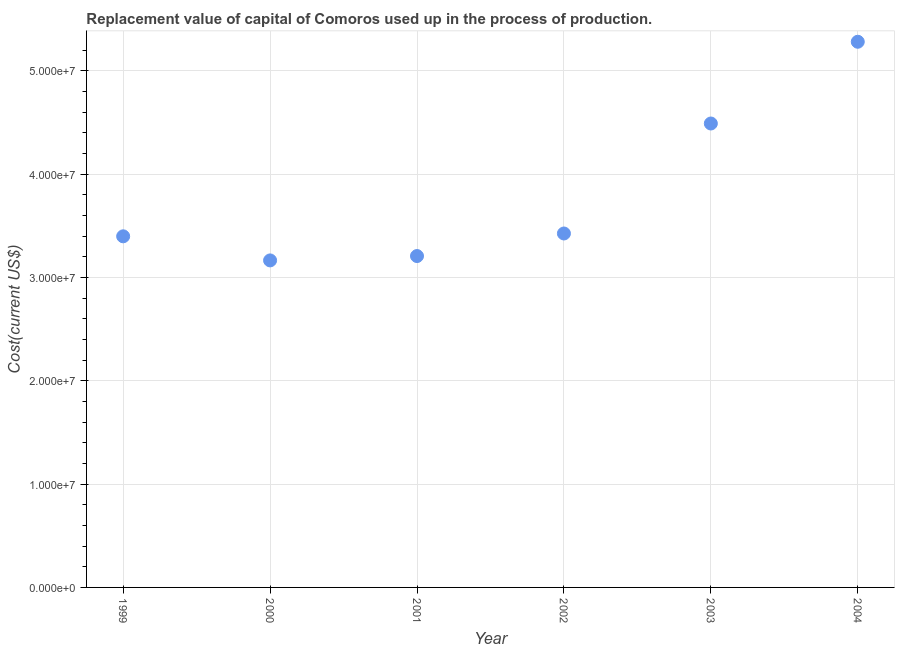What is the consumption of fixed capital in 2002?
Make the answer very short. 3.43e+07. Across all years, what is the maximum consumption of fixed capital?
Offer a very short reply. 5.28e+07. Across all years, what is the minimum consumption of fixed capital?
Your response must be concise. 3.16e+07. In which year was the consumption of fixed capital minimum?
Your response must be concise. 2000. What is the sum of the consumption of fixed capital?
Ensure brevity in your answer.  2.30e+08. What is the difference between the consumption of fixed capital in 1999 and 2001?
Make the answer very short. 1.91e+06. What is the average consumption of fixed capital per year?
Make the answer very short. 3.83e+07. What is the median consumption of fixed capital?
Ensure brevity in your answer.  3.41e+07. Do a majority of the years between 2000 and 2001 (inclusive) have consumption of fixed capital greater than 50000000 US$?
Provide a succinct answer. No. What is the ratio of the consumption of fixed capital in 2000 to that in 2004?
Your answer should be very brief. 0.6. What is the difference between the highest and the second highest consumption of fixed capital?
Your answer should be very brief. 7.91e+06. Is the sum of the consumption of fixed capital in 1999 and 2000 greater than the maximum consumption of fixed capital across all years?
Provide a short and direct response. Yes. What is the difference between the highest and the lowest consumption of fixed capital?
Make the answer very short. 2.12e+07. In how many years, is the consumption of fixed capital greater than the average consumption of fixed capital taken over all years?
Provide a succinct answer. 2. How many dotlines are there?
Keep it short and to the point. 1. How many years are there in the graph?
Your answer should be compact. 6. Are the values on the major ticks of Y-axis written in scientific E-notation?
Provide a short and direct response. Yes. Does the graph contain any zero values?
Provide a short and direct response. No. Does the graph contain grids?
Keep it short and to the point. Yes. What is the title of the graph?
Offer a terse response. Replacement value of capital of Comoros used up in the process of production. What is the label or title of the X-axis?
Offer a terse response. Year. What is the label or title of the Y-axis?
Give a very brief answer. Cost(current US$). What is the Cost(current US$) in 1999?
Offer a very short reply. 3.40e+07. What is the Cost(current US$) in 2000?
Your response must be concise. 3.16e+07. What is the Cost(current US$) in 2001?
Your answer should be compact. 3.21e+07. What is the Cost(current US$) in 2002?
Ensure brevity in your answer.  3.43e+07. What is the Cost(current US$) in 2003?
Your answer should be very brief. 4.49e+07. What is the Cost(current US$) in 2004?
Keep it short and to the point. 5.28e+07. What is the difference between the Cost(current US$) in 1999 and 2000?
Provide a succinct answer. 2.33e+06. What is the difference between the Cost(current US$) in 1999 and 2001?
Your answer should be very brief. 1.91e+06. What is the difference between the Cost(current US$) in 1999 and 2002?
Provide a succinct answer. -2.74e+05. What is the difference between the Cost(current US$) in 1999 and 2003?
Your response must be concise. -1.09e+07. What is the difference between the Cost(current US$) in 1999 and 2004?
Ensure brevity in your answer.  -1.88e+07. What is the difference between the Cost(current US$) in 2000 and 2001?
Provide a succinct answer. -4.23e+05. What is the difference between the Cost(current US$) in 2000 and 2002?
Ensure brevity in your answer.  -2.61e+06. What is the difference between the Cost(current US$) in 2000 and 2003?
Keep it short and to the point. -1.32e+07. What is the difference between the Cost(current US$) in 2000 and 2004?
Make the answer very short. -2.12e+07. What is the difference between the Cost(current US$) in 2001 and 2002?
Ensure brevity in your answer.  -2.18e+06. What is the difference between the Cost(current US$) in 2001 and 2003?
Provide a short and direct response. -1.28e+07. What is the difference between the Cost(current US$) in 2001 and 2004?
Make the answer very short. -2.07e+07. What is the difference between the Cost(current US$) in 2002 and 2003?
Your answer should be very brief. -1.06e+07. What is the difference between the Cost(current US$) in 2002 and 2004?
Your answer should be compact. -1.86e+07. What is the difference between the Cost(current US$) in 2003 and 2004?
Provide a succinct answer. -7.91e+06. What is the ratio of the Cost(current US$) in 1999 to that in 2000?
Your answer should be very brief. 1.07. What is the ratio of the Cost(current US$) in 1999 to that in 2001?
Offer a very short reply. 1.06. What is the ratio of the Cost(current US$) in 1999 to that in 2002?
Your answer should be very brief. 0.99. What is the ratio of the Cost(current US$) in 1999 to that in 2003?
Ensure brevity in your answer.  0.76. What is the ratio of the Cost(current US$) in 1999 to that in 2004?
Keep it short and to the point. 0.64. What is the ratio of the Cost(current US$) in 2000 to that in 2001?
Provide a short and direct response. 0.99. What is the ratio of the Cost(current US$) in 2000 to that in 2002?
Your answer should be very brief. 0.92. What is the ratio of the Cost(current US$) in 2000 to that in 2003?
Ensure brevity in your answer.  0.7. What is the ratio of the Cost(current US$) in 2000 to that in 2004?
Your answer should be compact. 0.6. What is the ratio of the Cost(current US$) in 2001 to that in 2002?
Your answer should be compact. 0.94. What is the ratio of the Cost(current US$) in 2001 to that in 2003?
Your answer should be compact. 0.71. What is the ratio of the Cost(current US$) in 2001 to that in 2004?
Make the answer very short. 0.61. What is the ratio of the Cost(current US$) in 2002 to that in 2003?
Keep it short and to the point. 0.76. What is the ratio of the Cost(current US$) in 2002 to that in 2004?
Provide a succinct answer. 0.65. 